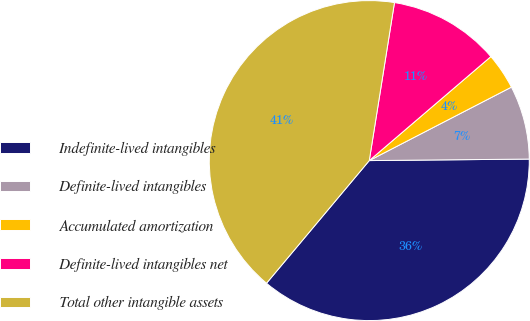Convert chart. <chart><loc_0><loc_0><loc_500><loc_500><pie_chart><fcel>Indefinite-lived intangibles<fcel>Definite-lived intangibles<fcel>Accumulated amortization<fcel>Definite-lived intangibles net<fcel>Total other intangible assets<nl><fcel>36.25%<fcel>7.44%<fcel>3.67%<fcel>11.22%<fcel>41.42%<nl></chart> 